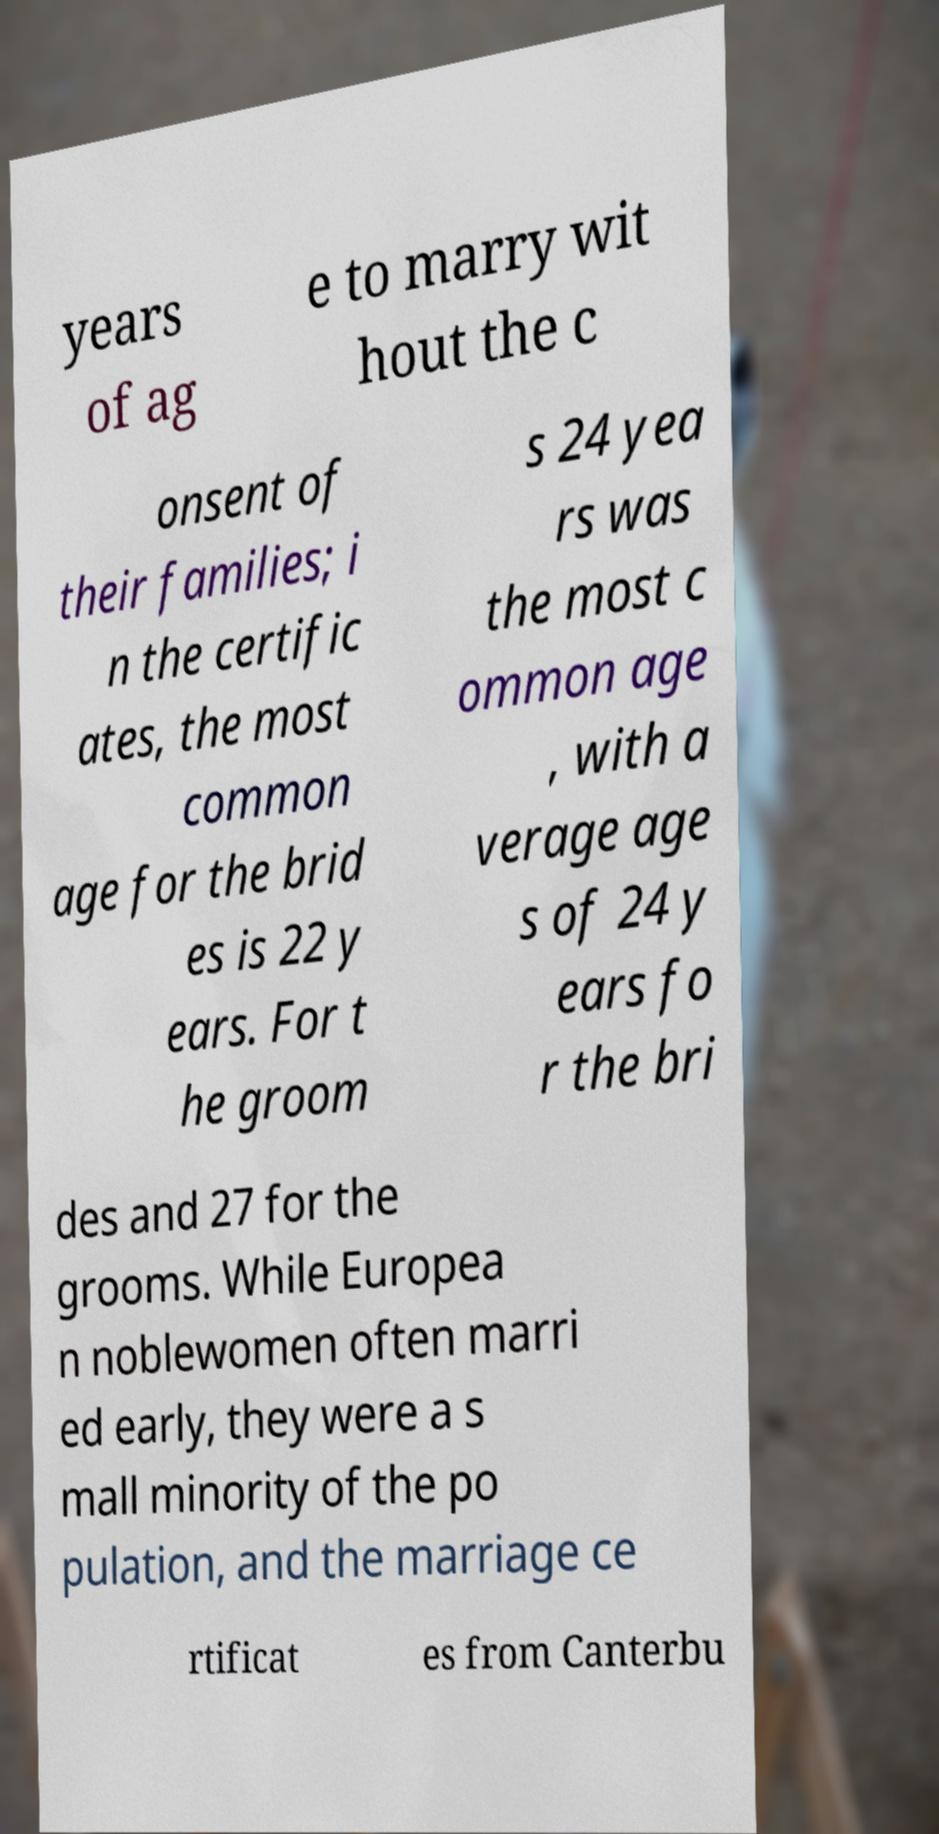What messages or text are displayed in this image? I need them in a readable, typed format. years of ag e to marry wit hout the c onsent of their families; i n the certific ates, the most common age for the brid es is 22 y ears. For t he groom s 24 yea rs was the most c ommon age , with a verage age s of 24 y ears fo r the bri des and 27 for the grooms. While Europea n noblewomen often marri ed early, they were a s mall minority of the po pulation, and the marriage ce rtificat es from Canterbu 